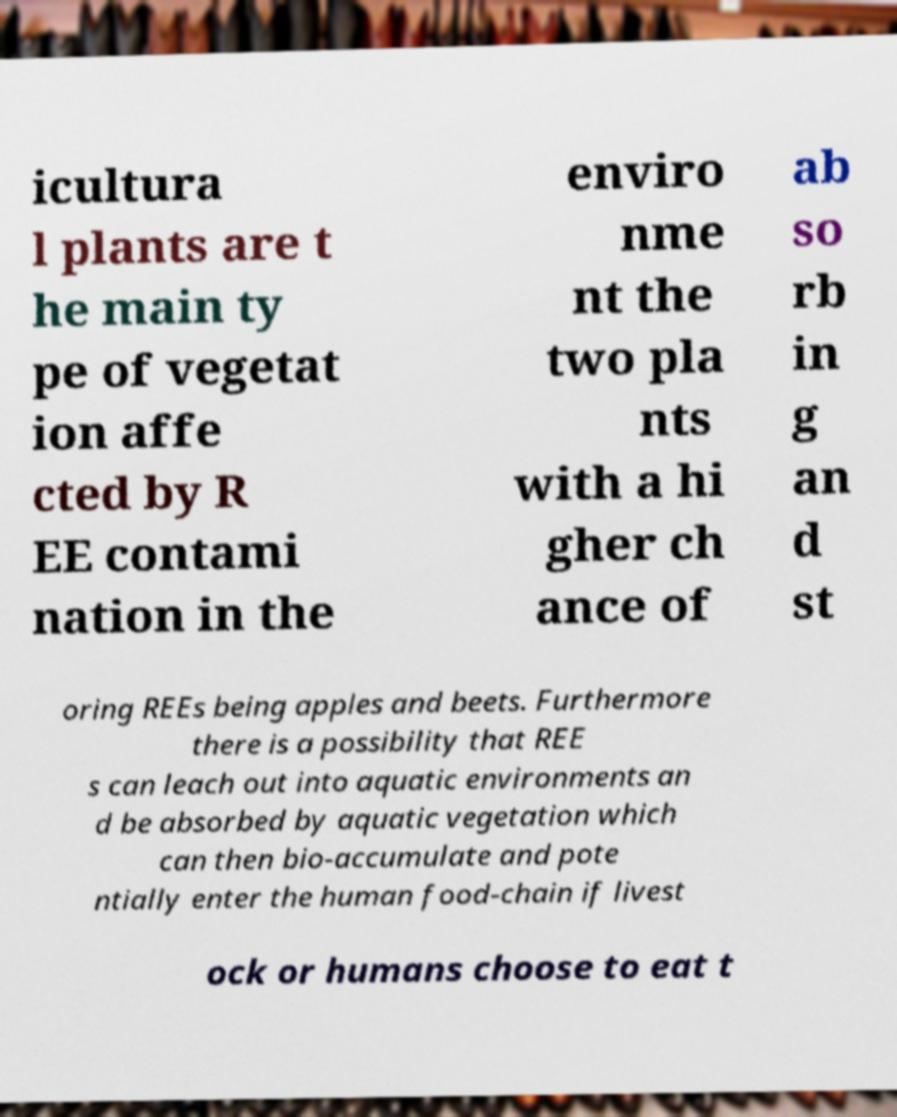Can you read and provide the text displayed in the image?This photo seems to have some interesting text. Can you extract and type it out for me? icultura l plants are t he main ty pe of vegetat ion affe cted by R EE contami nation in the enviro nme nt the two pla nts with a hi gher ch ance of ab so rb in g an d st oring REEs being apples and beets. Furthermore there is a possibility that REE s can leach out into aquatic environments an d be absorbed by aquatic vegetation which can then bio-accumulate and pote ntially enter the human food-chain if livest ock or humans choose to eat t 